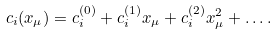Convert formula to latex. <formula><loc_0><loc_0><loc_500><loc_500>c _ { i } ( x _ { \mu } ) = c _ { i } ^ { ( 0 ) } + c _ { i } ^ { ( 1 ) } x _ { \mu } + c _ { i } ^ { ( 2 ) } x _ { \mu } ^ { 2 } + \dots .</formula> 